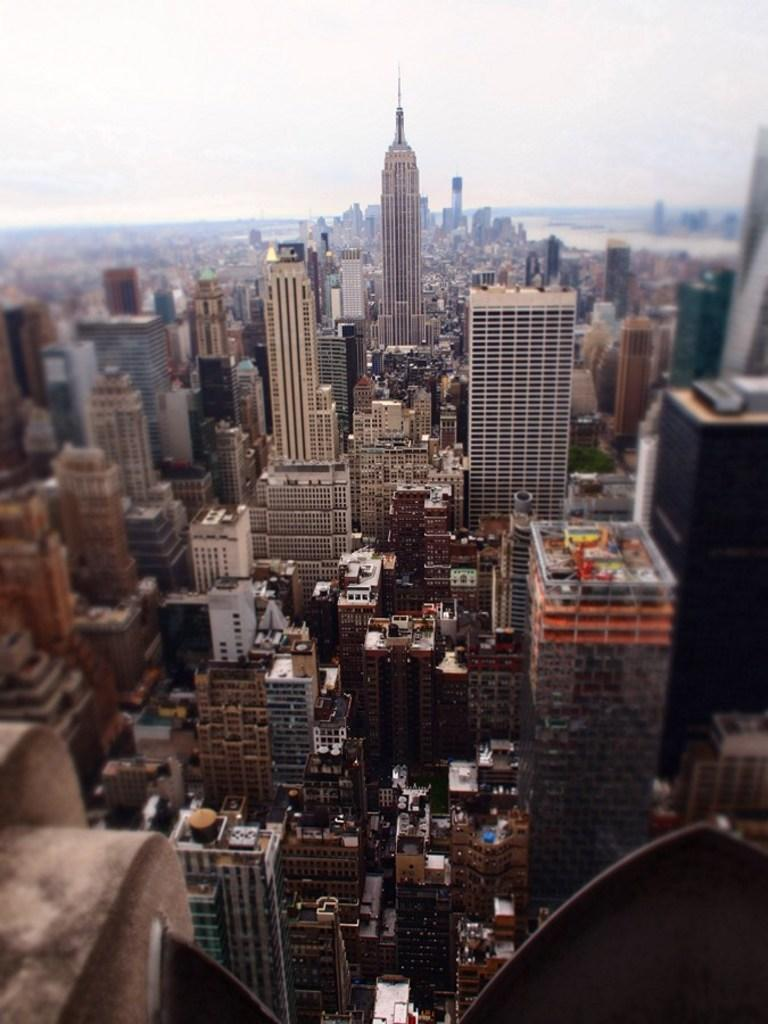What type of location is shown in the image? The image depicts a city. What are the tall buildings in the image called? There are skyscrapers in the image. What type of buildings can be seen at the bottom of the image? There are buildings at the bottom of the image. What natural element is visible in the image? There is water visible in the image. What is visible at the top of the image? The sky is visible at the top of the image. What can be seen in the sky? Clouds are present in the sky. What type of basket is being used by the queen in the image? There is no queen or basket present in the image. What type of competition is taking place in the image? There is no competition present in the image. 